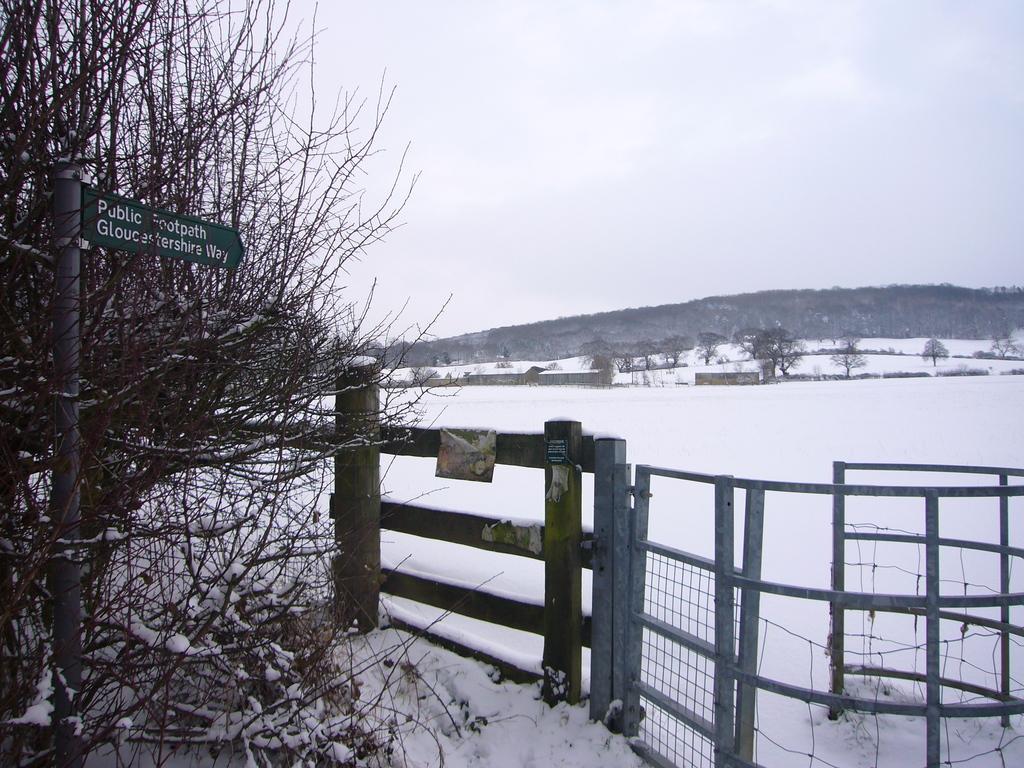Please provide a concise description of this image. This image consists of a plant. And we can see a board fixed to a pole. On the right, there is a gate and the fencing. At the bottom, there is snow. In the background, we can see a mountain. At the top, there are clouds in the sky. 